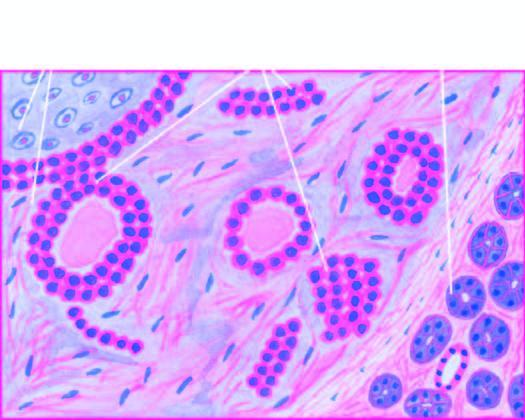s part of the endocervical mucosa comprised of ducts, acini, tubules, sheets and strands of cuboidal and myoepithelial cells?
Answer the question using a single word or phrase. No 